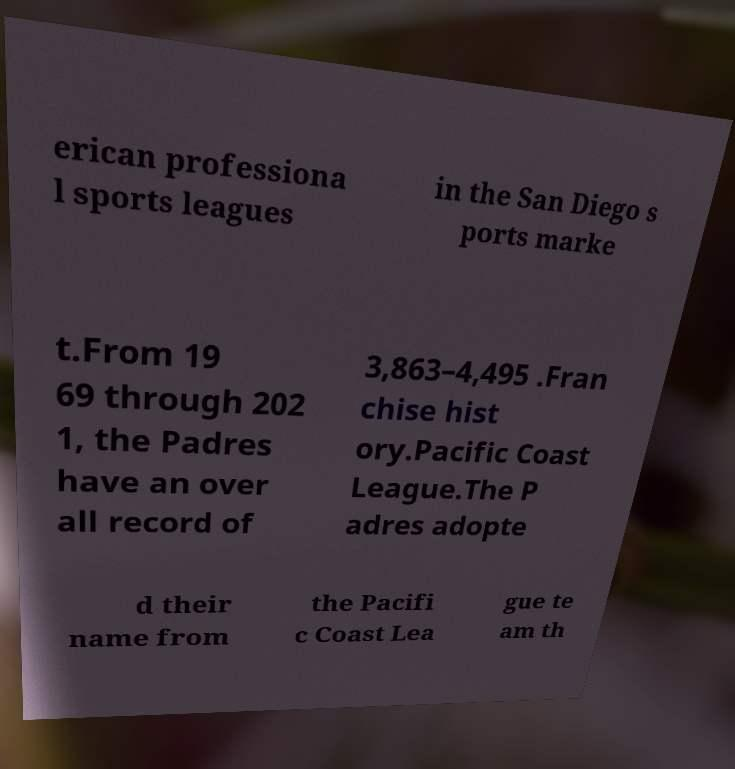Can you accurately transcribe the text from the provided image for me? erican professiona l sports leagues in the San Diego s ports marke t.From 19 69 through 202 1, the Padres have an over all record of 3,863–4,495 .Fran chise hist ory.Pacific Coast League.The P adres adopte d their name from the Pacifi c Coast Lea gue te am th 